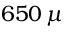<formula> <loc_0><loc_0><loc_500><loc_500>6 5 0 \, \mu</formula> 